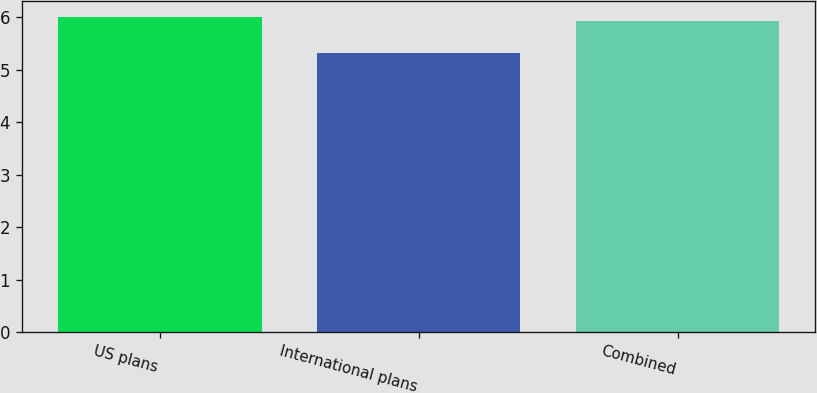Convert chart to OTSL. <chart><loc_0><loc_0><loc_500><loc_500><bar_chart><fcel>US plans<fcel>International plans<fcel>Combined<nl><fcel>6<fcel>5.31<fcel>5.93<nl></chart> 